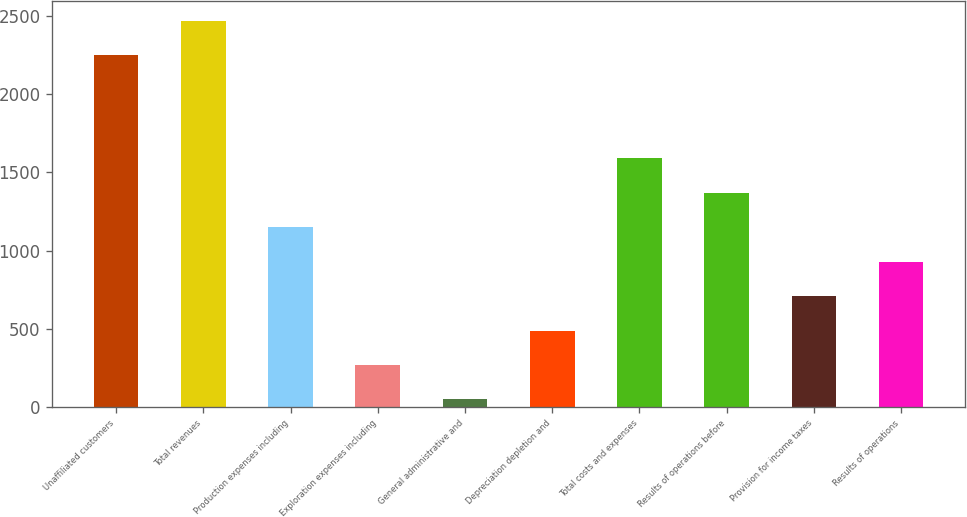Convert chart. <chart><loc_0><loc_0><loc_500><loc_500><bar_chart><fcel>Unaffiliated customers<fcel>Total revenues<fcel>Production expenses including<fcel>Exploration expenses including<fcel>General administrative and<fcel>Depreciation depletion and<fcel>Total costs and expenses<fcel>Results of operations before<fcel>Provision for income taxes<fcel>Results of operations<nl><fcel>2251<fcel>2471.3<fcel>1149.5<fcel>268.3<fcel>48<fcel>488.6<fcel>1590.1<fcel>1369.8<fcel>708.9<fcel>929.2<nl></chart> 